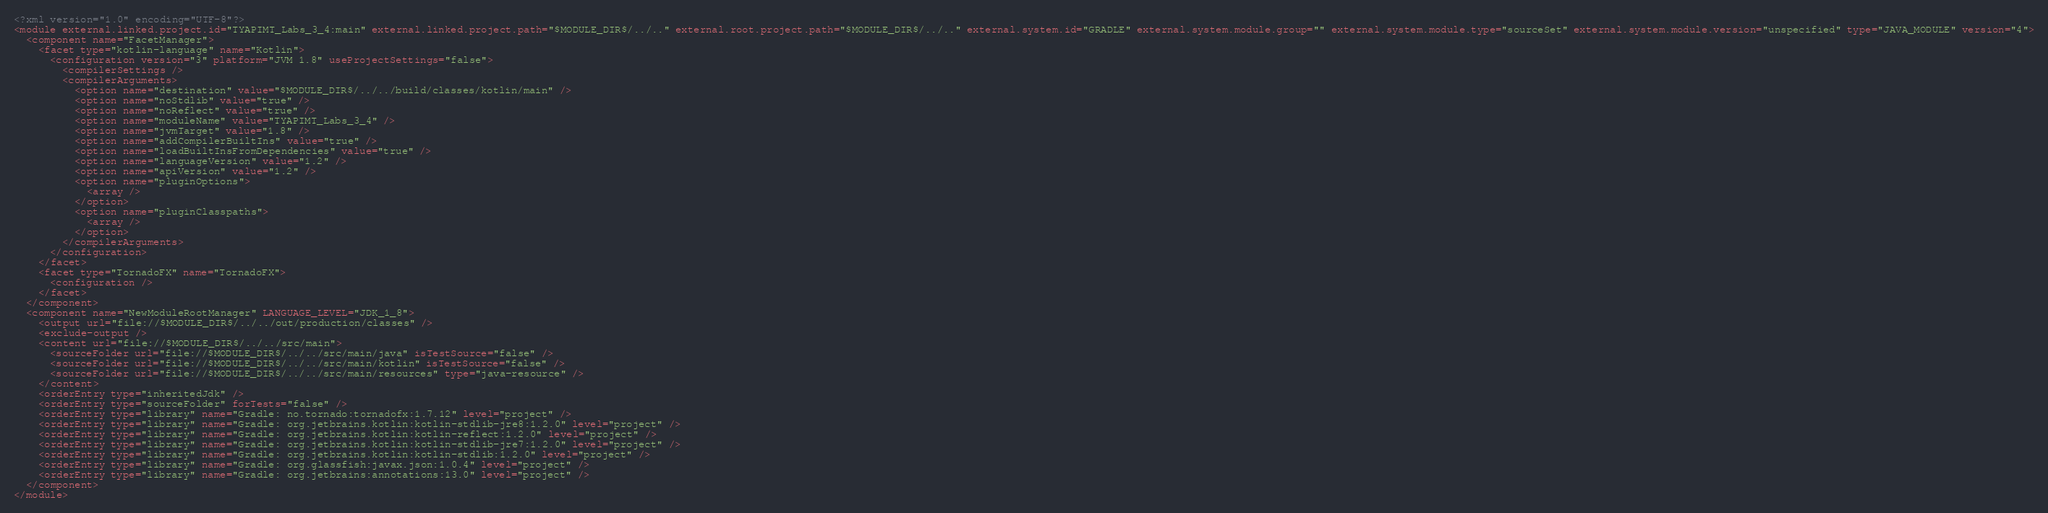Convert code to text. <code><loc_0><loc_0><loc_500><loc_500><_XML_><?xml version="1.0" encoding="UTF-8"?>
<module external.linked.project.id="TYAPIMT_Labs_3_4:main" external.linked.project.path="$MODULE_DIR$/../.." external.root.project.path="$MODULE_DIR$/../.." external.system.id="GRADLE" external.system.module.group="" external.system.module.type="sourceSet" external.system.module.version="unspecified" type="JAVA_MODULE" version="4">
  <component name="FacetManager">
    <facet type="kotlin-language" name="Kotlin">
      <configuration version="3" platform="JVM 1.8" useProjectSettings="false">
        <compilerSettings />
        <compilerArguments>
          <option name="destination" value="$MODULE_DIR$/../../build/classes/kotlin/main" />
          <option name="noStdlib" value="true" />
          <option name="noReflect" value="true" />
          <option name="moduleName" value="TYAPIMT_Labs_3_4" />
          <option name="jvmTarget" value="1.8" />
          <option name="addCompilerBuiltIns" value="true" />
          <option name="loadBuiltInsFromDependencies" value="true" />
          <option name="languageVersion" value="1.2" />
          <option name="apiVersion" value="1.2" />
          <option name="pluginOptions">
            <array />
          </option>
          <option name="pluginClasspaths">
            <array />
          </option>
        </compilerArguments>
      </configuration>
    </facet>
    <facet type="TornadoFX" name="TornadoFX">
      <configuration />
    </facet>
  </component>
  <component name="NewModuleRootManager" LANGUAGE_LEVEL="JDK_1_8">
    <output url="file://$MODULE_DIR$/../../out/production/classes" />
    <exclude-output />
    <content url="file://$MODULE_DIR$/../../src/main">
      <sourceFolder url="file://$MODULE_DIR$/../../src/main/java" isTestSource="false" />
      <sourceFolder url="file://$MODULE_DIR$/../../src/main/kotlin" isTestSource="false" />
      <sourceFolder url="file://$MODULE_DIR$/../../src/main/resources" type="java-resource" />
    </content>
    <orderEntry type="inheritedJdk" />
    <orderEntry type="sourceFolder" forTests="false" />
    <orderEntry type="library" name="Gradle: no.tornado:tornadofx:1.7.12" level="project" />
    <orderEntry type="library" name="Gradle: org.jetbrains.kotlin:kotlin-stdlib-jre8:1.2.0" level="project" />
    <orderEntry type="library" name="Gradle: org.jetbrains.kotlin:kotlin-reflect:1.2.0" level="project" />
    <orderEntry type="library" name="Gradle: org.jetbrains.kotlin:kotlin-stdlib-jre7:1.2.0" level="project" />
    <orderEntry type="library" name="Gradle: org.jetbrains.kotlin:kotlin-stdlib:1.2.0" level="project" />
    <orderEntry type="library" name="Gradle: org.glassfish:javax.json:1.0.4" level="project" />
    <orderEntry type="library" name="Gradle: org.jetbrains:annotations:13.0" level="project" />
  </component>
</module></code> 